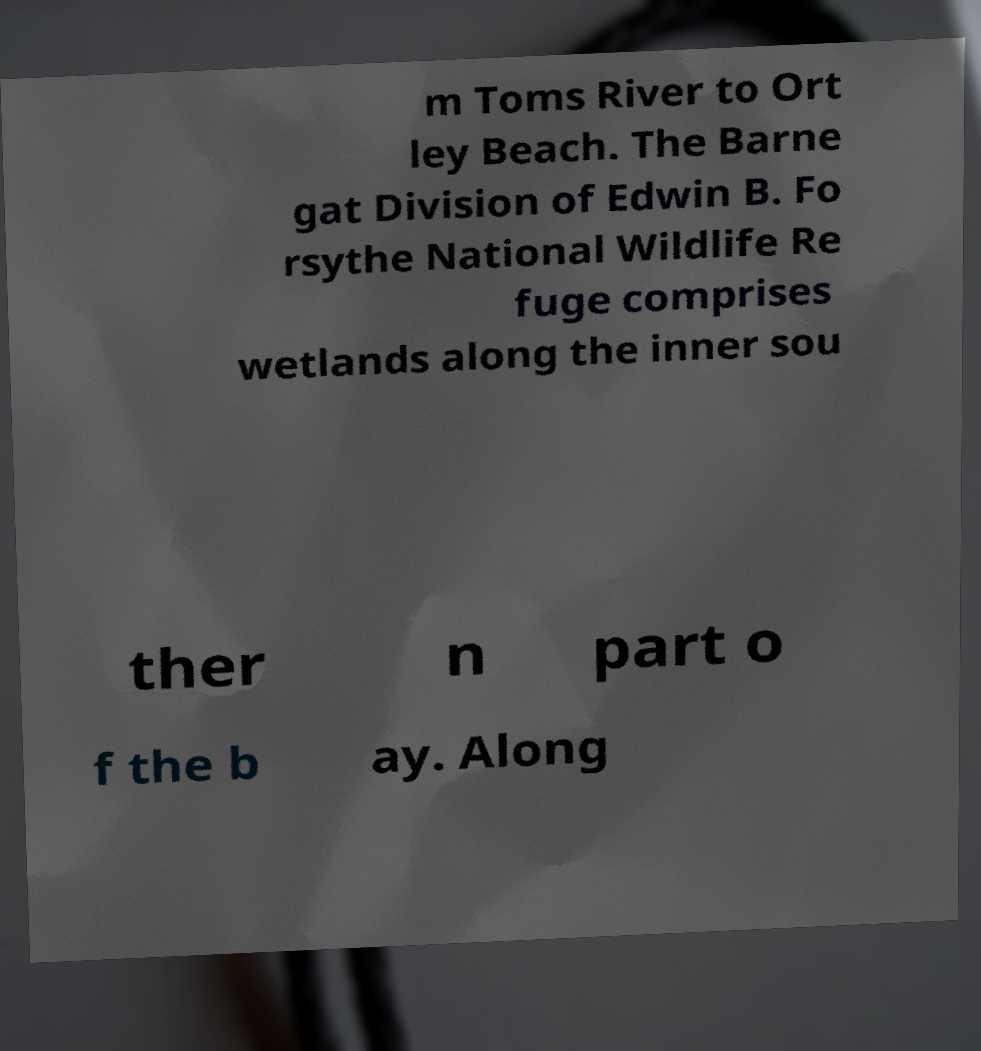I need the written content from this picture converted into text. Can you do that? m Toms River to Ort ley Beach. The Barne gat Division of Edwin B. Fo rsythe National Wildlife Re fuge comprises wetlands along the inner sou ther n part o f the b ay. Along 